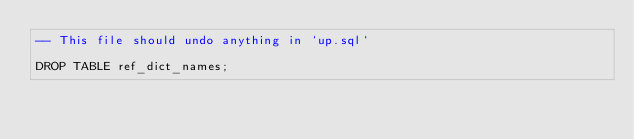Convert code to text. <code><loc_0><loc_0><loc_500><loc_500><_SQL_>-- This file should undo anything in `up.sql`

DROP TABLE ref_dict_names;
</code> 